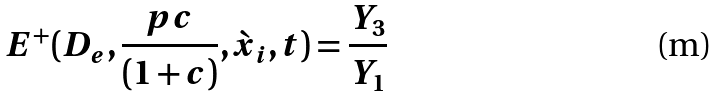Convert formula to latex. <formula><loc_0><loc_0><loc_500><loc_500>E ^ { + } ( D _ { e } , \frac { p c } { ( 1 + c ) } , { \grave { x } _ { i } } , t ) = \frac { Y _ { 3 } } { Y _ { 1 } }</formula> 